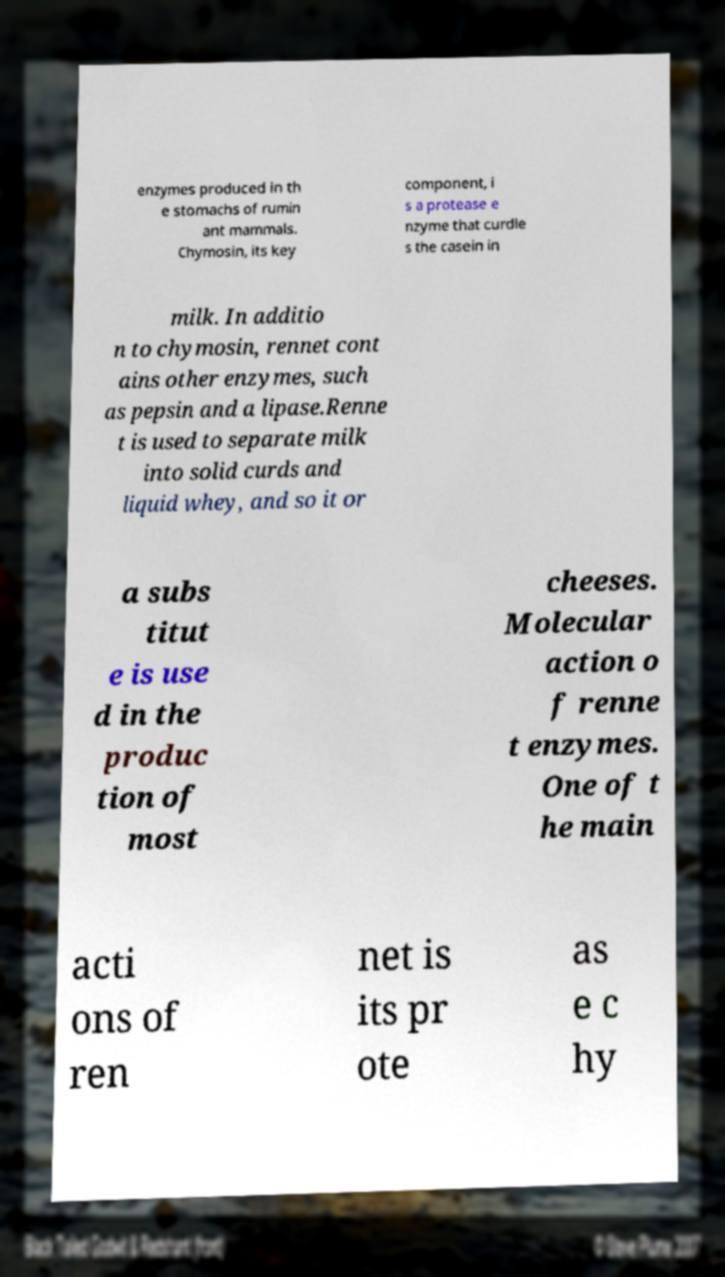Could you extract and type out the text from this image? enzymes produced in th e stomachs of rumin ant mammals. Chymosin, its key component, i s a protease e nzyme that curdle s the casein in milk. In additio n to chymosin, rennet cont ains other enzymes, such as pepsin and a lipase.Renne t is used to separate milk into solid curds and liquid whey, and so it or a subs titut e is use d in the produc tion of most cheeses. Molecular action o f renne t enzymes. One of t he main acti ons of ren net is its pr ote as e c hy 